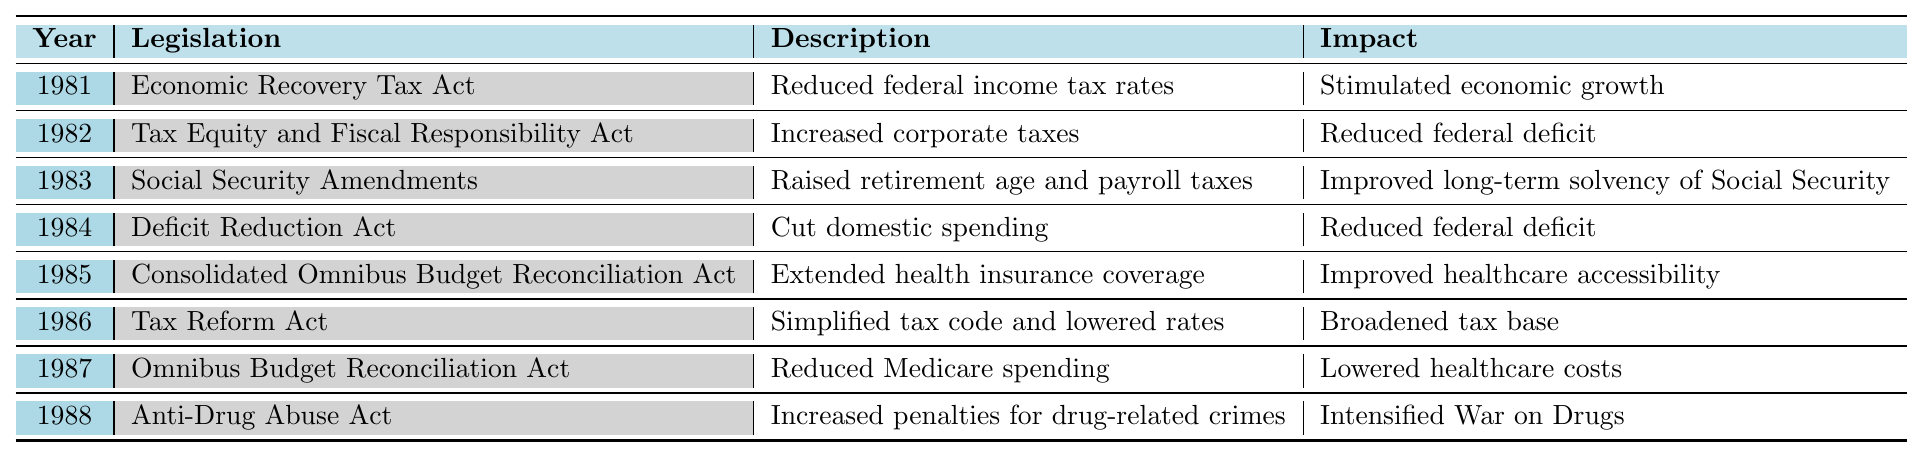What legislation was passed in 1983? The table shows that the legislation passed in 1983 was the "Social Security Amendments."
Answer: Social Security Amendments What year did the Economic Recovery Tax Act take place? According to the table, the Economic Recovery Tax Act was enacted in 1981.
Answer: 1981 Which legislation focused on improving healthcare accessibility? From the table, the "Consolidated Omnibus Budget Reconciliation Act" is indicated to have improved healthcare accessibility.
Answer: Consolidated Omnibus Budget Reconciliation Act How many legislative actions aimed to reduce the federal deficit? The table indicates three legislative actions aimed at reducing the federal deficit: the Tax Equity and Fiscal Responsibility Act, the Deficit Reduction Act, and the Omnibus Budget Reconciliation Act.
Answer: 3 Did any legislation in 1986 lead to a broadened tax base? The table confirms that the Tax Reform Act in 1986 resulted in a broadened tax base.
Answer: Yes In which years was domestic spending cut? The table reveals that domestic spending was cut in 1984 through the Deficit Reduction Act.
Answer: 1984 What is the relationship between the years 1981 and 1986 in terms of economic measures? In both years, significant legislative actions were taken to address taxes; 1981 introduced the Economic Recovery Tax Act, and 1986 enacted the Tax Reform Act, both aimed at stimulating economic conditions.
Answer: Both aimed to stimulate the economy Which legislation was aimed at the War on Drugs? The legislation aimed at the War on Drugs is the Anti-Drug Abuse Act, passed in 1988 according to the table.
Answer: Anti-Drug Abuse Act What was the impact of the Social Security Amendments? The table states that the impact of the Social Security Amendments was to improve the long-term solvency of Social Security.
Answer: Improved long-term solvency of Social Security List all significant pieces of legislation passed in Reagan's second term (1985-1988). The table identifies four pieces of legislation from 1985 to 1988: the Consolidated Omnibus Budget Reconciliation Act (1985), the Tax Reform Act (1986), the Omnibus Budget Reconciliation Act (1987), and the Anti-Drug Abuse Act (1988).
Answer: 4 